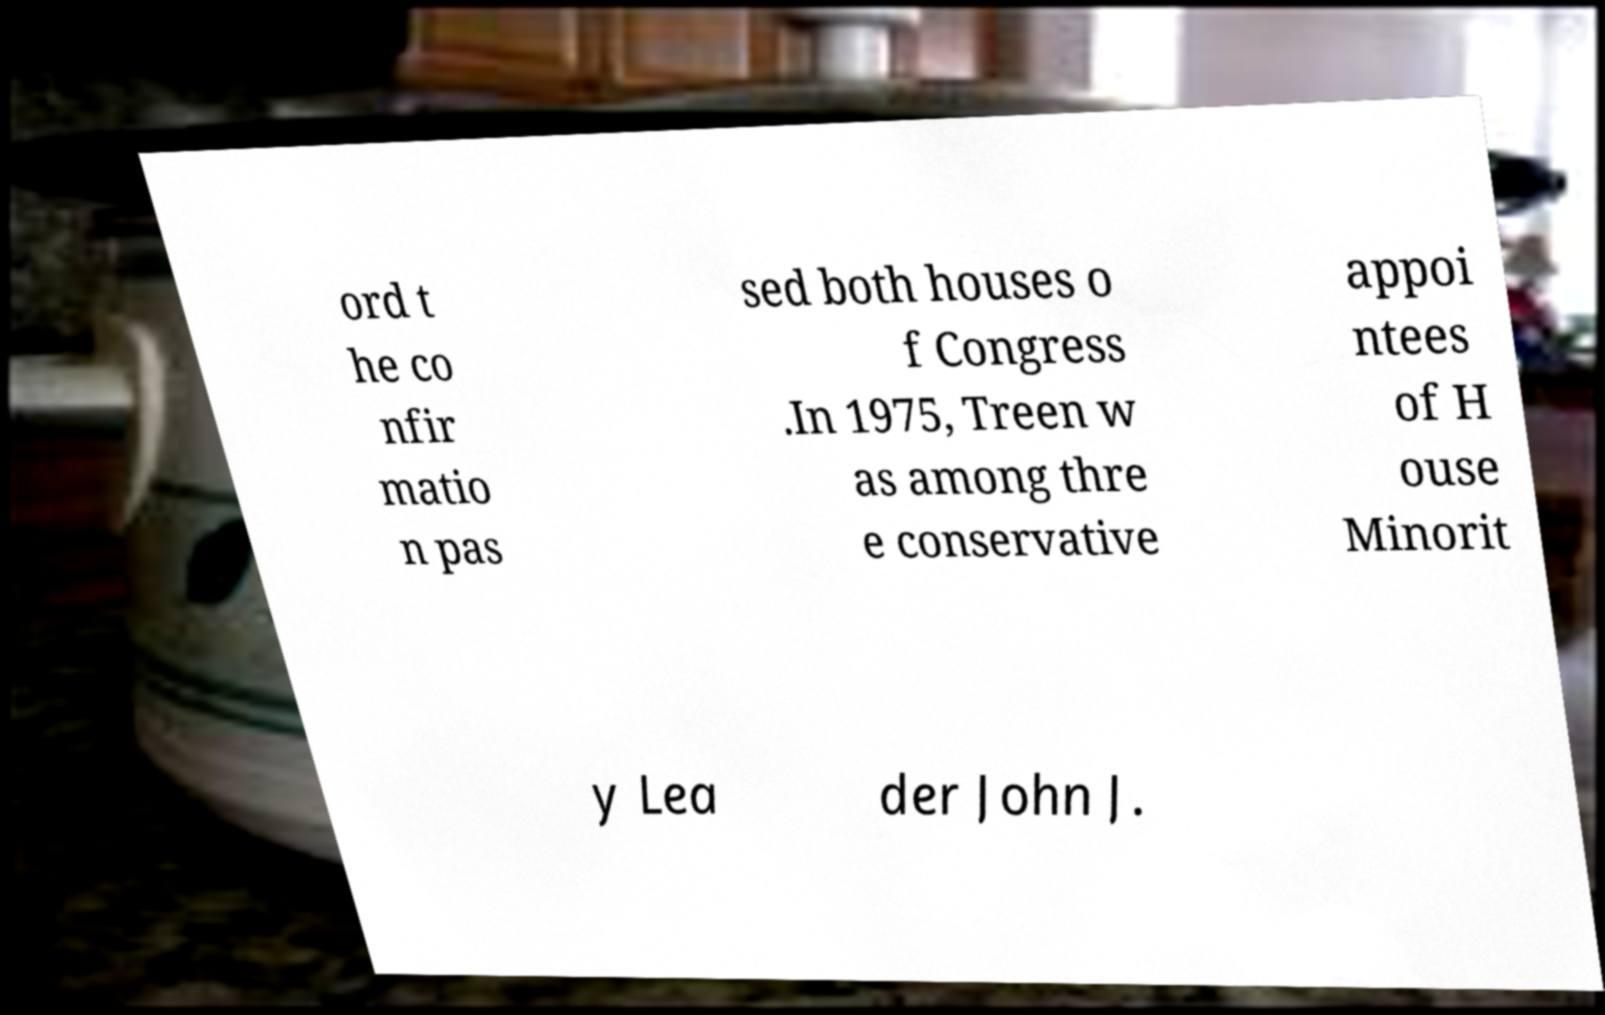There's text embedded in this image that I need extracted. Can you transcribe it verbatim? ord t he co nfir matio n pas sed both houses o f Congress .In 1975, Treen w as among thre e conservative appoi ntees of H ouse Minorit y Lea der John J. 